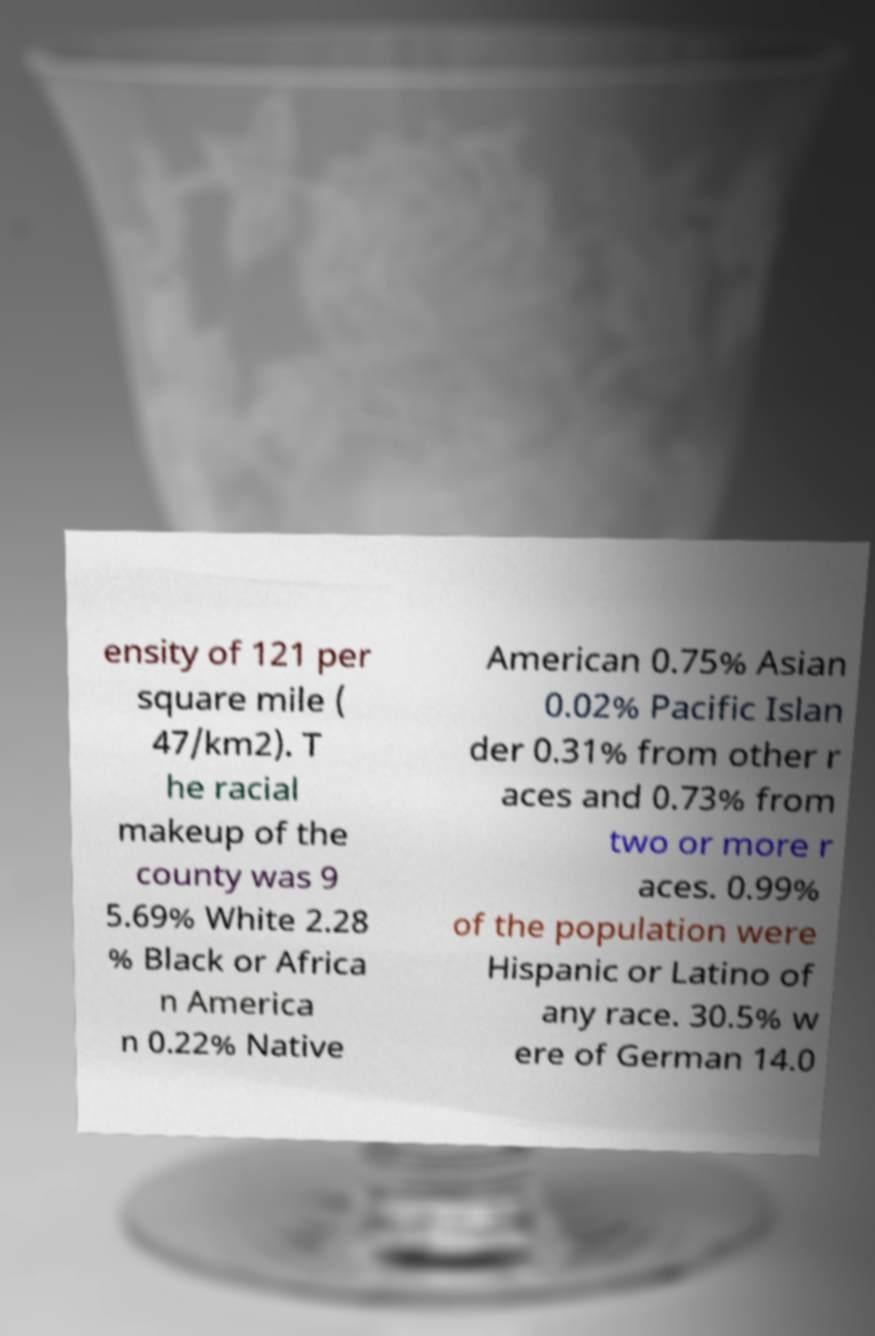There's text embedded in this image that I need extracted. Can you transcribe it verbatim? ensity of 121 per square mile ( 47/km2). T he racial makeup of the county was 9 5.69% White 2.28 % Black or Africa n America n 0.22% Native American 0.75% Asian 0.02% Pacific Islan der 0.31% from other r aces and 0.73% from two or more r aces. 0.99% of the population were Hispanic or Latino of any race. 30.5% w ere of German 14.0 